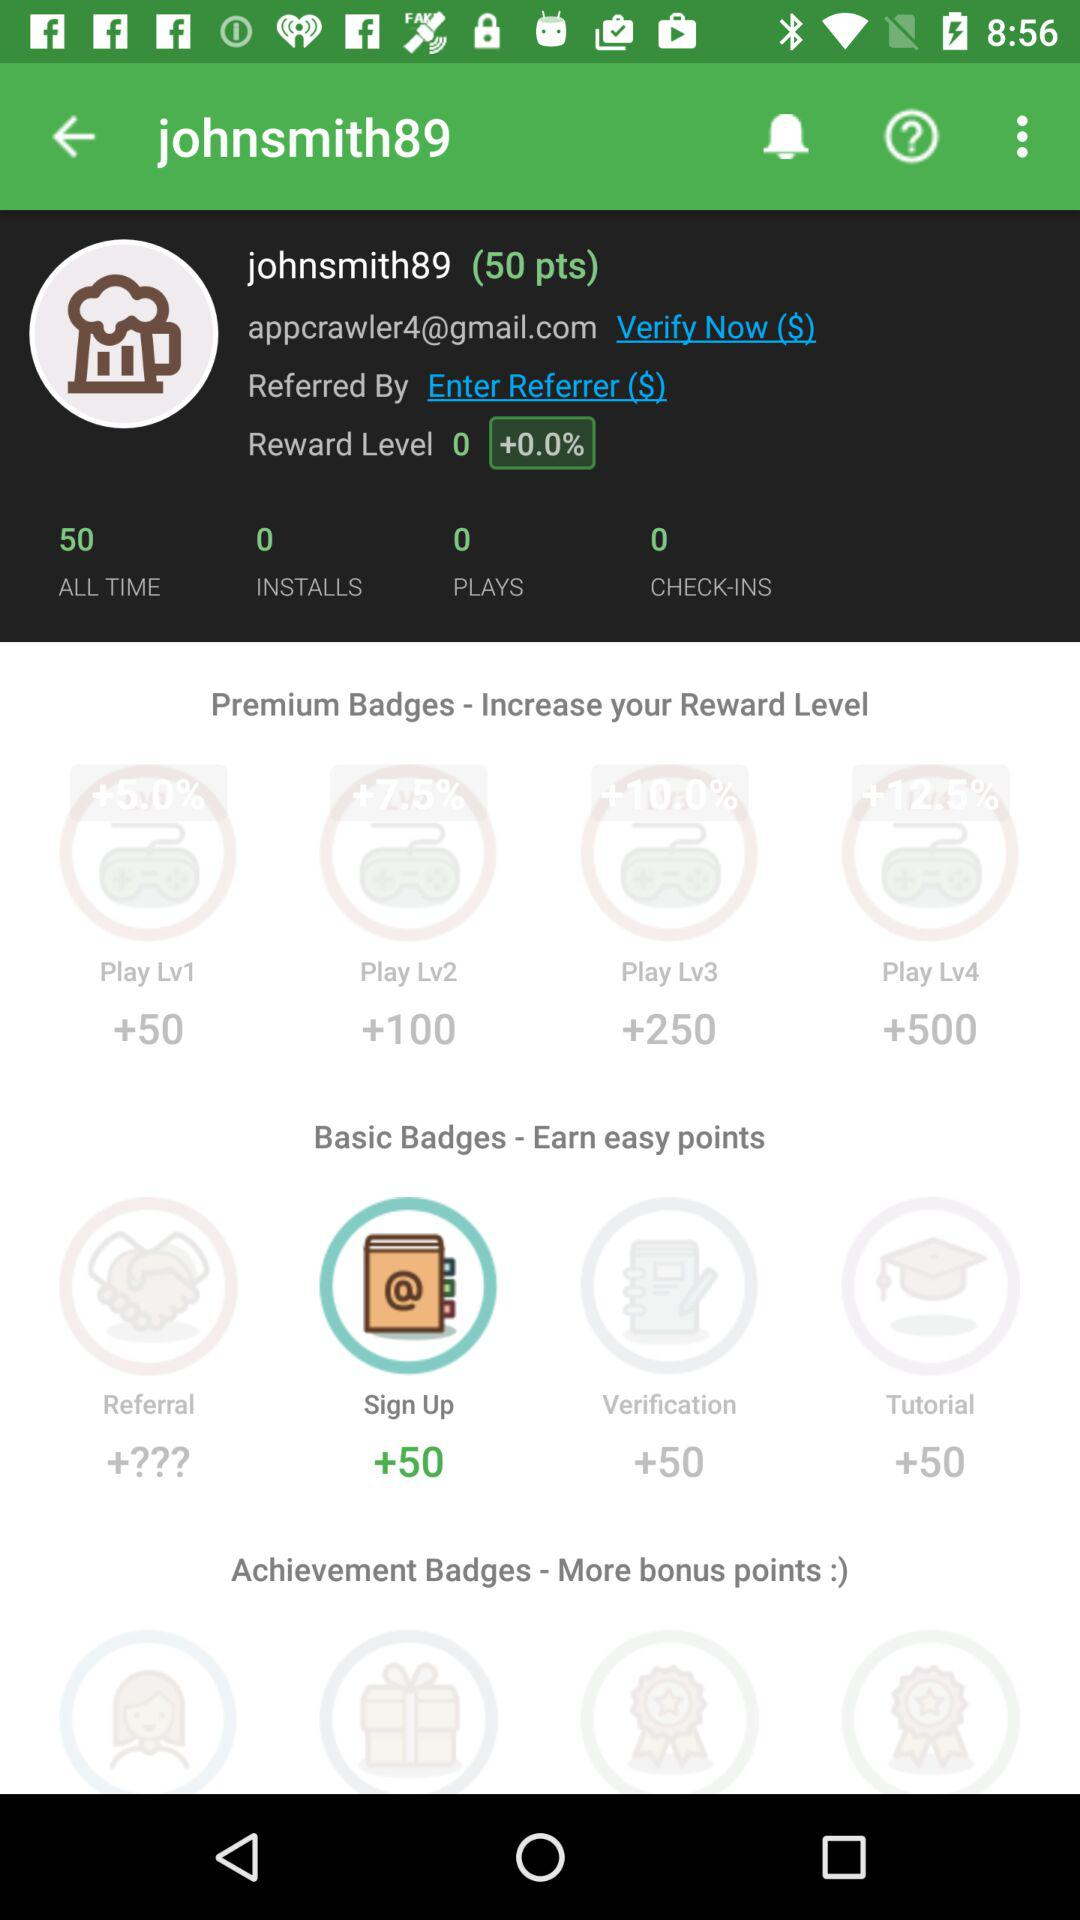What is the highest reward level?
Answer the question using a single word or phrase. 4 